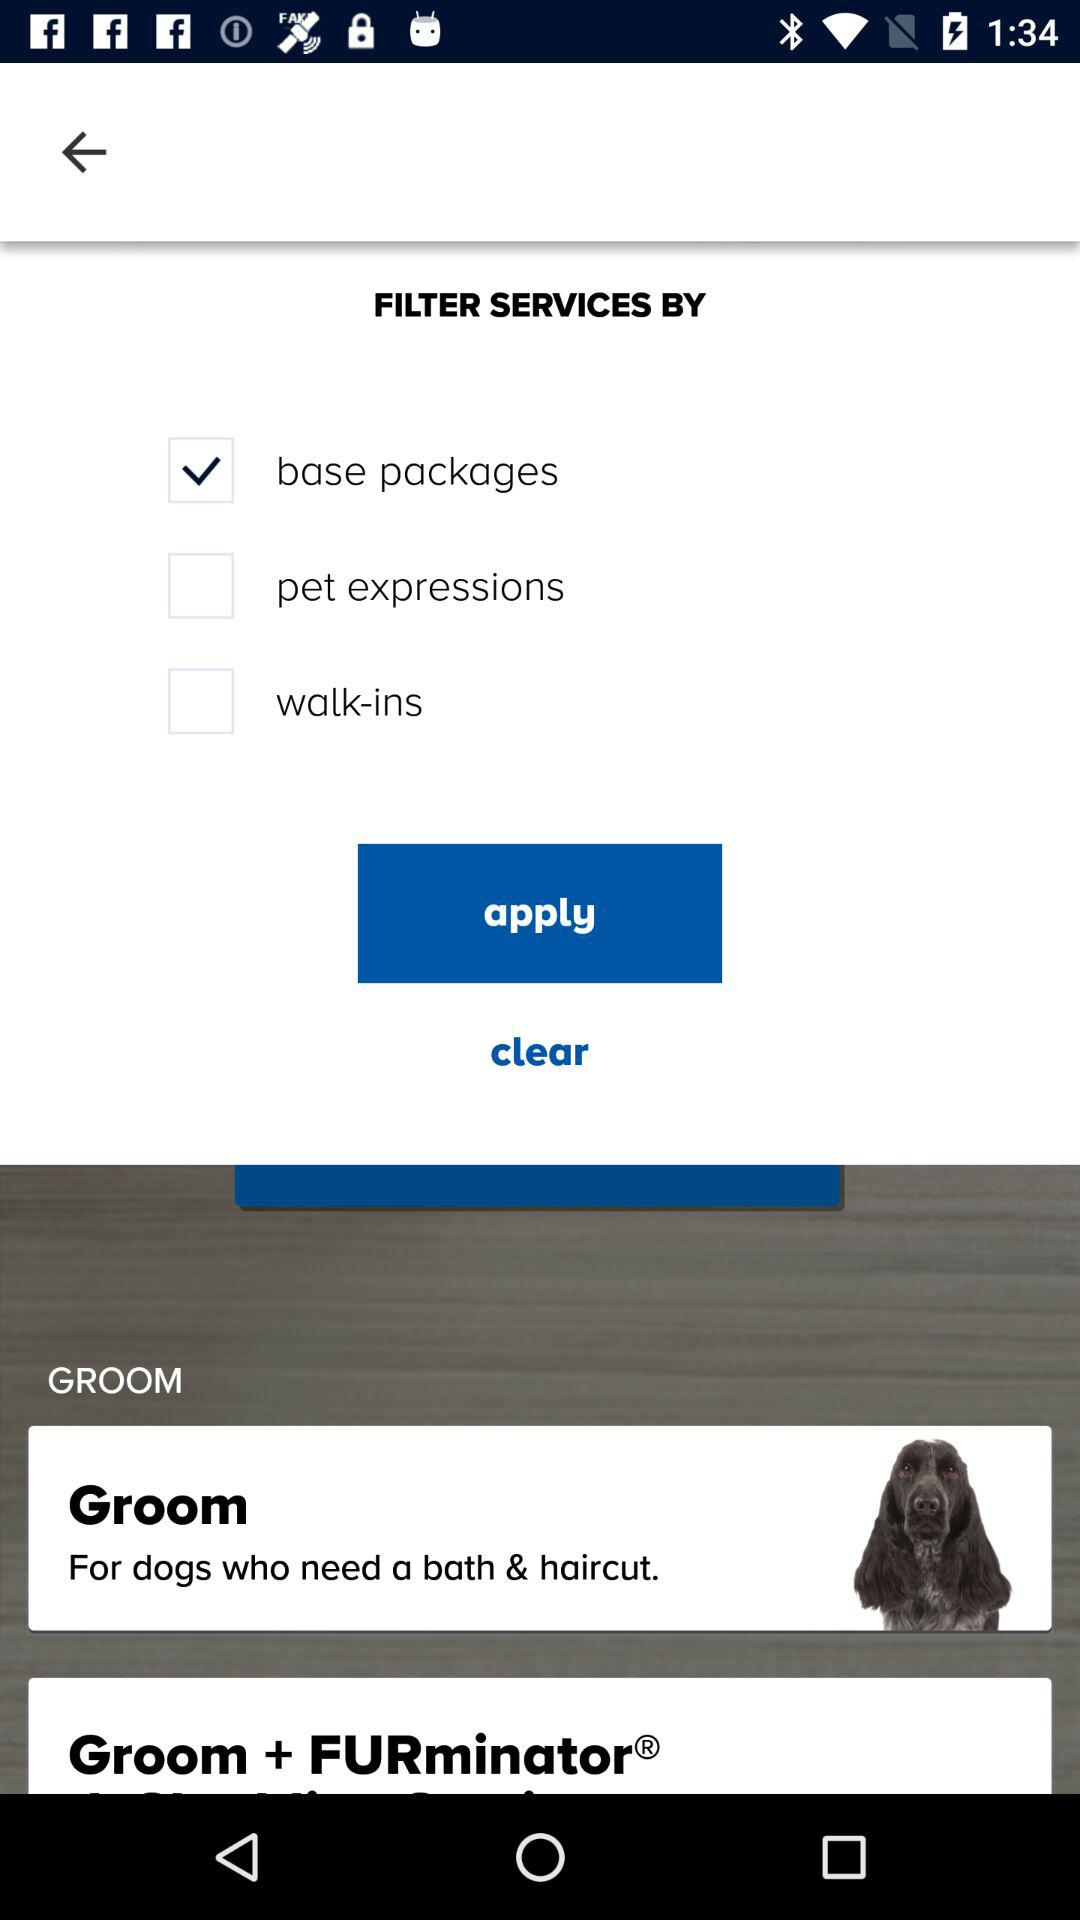How many services are offered by the grooming service?
Answer the question using a single word or phrase. 3 